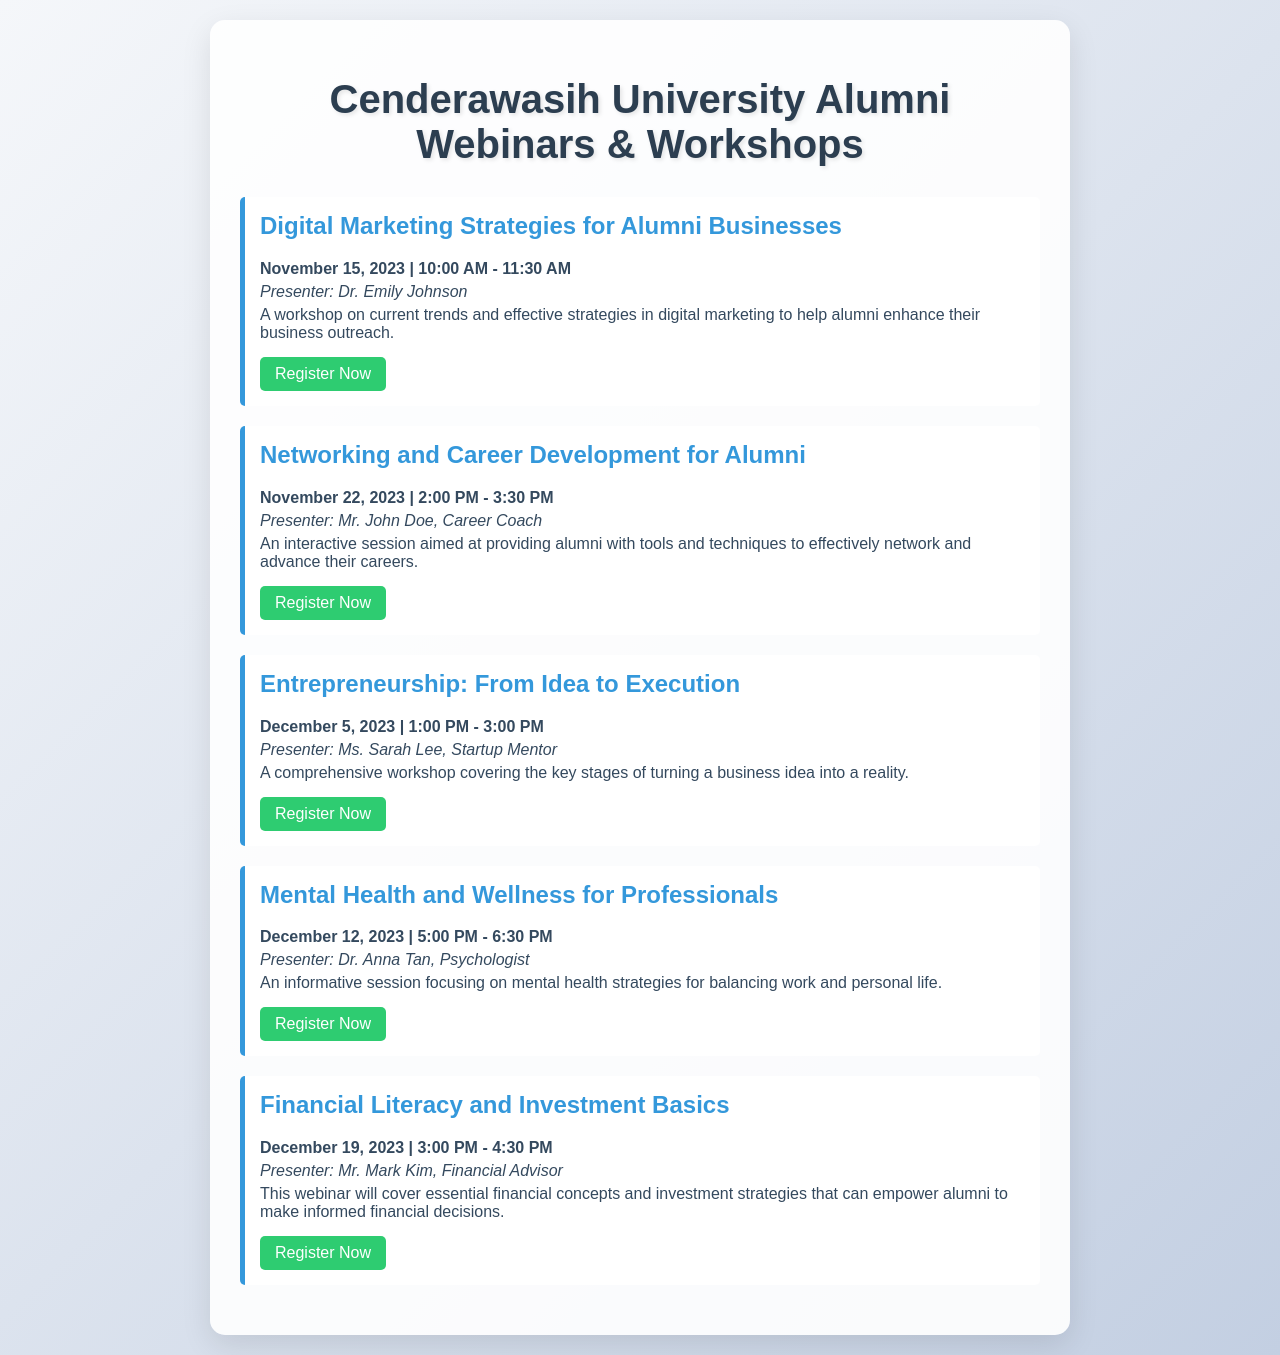What is the title of the first webinar? The title of the first webinar is listed as "Digital Marketing Strategies for Alumni Businesses."
Answer: Digital Marketing Strategies for Alumni Businesses Who is the presenter for the mental health webinar? The presenter for the mental health webinar is identified as Dr. Anna Tan, Psychologist.
Answer: Dr. Anna Tan What is the date of the entrepreneurship workshop? The date of the entrepreneurship workshop is specified as December 5, 2023.
Answer: December 5, 2023 How long is the networking session scheduled to last? The networking session is scheduled for 1.5 hours, from 2:00 PM to 3:30 PM.
Answer: 1.5 hours What is the focus of the financial literacy webinar? The focus of the financial literacy webinar is to cover essential financial concepts and investment strategies.
Answer: Financial concepts and investment strategies What is the link for registering for the digital marketing workshop? The link for registering for the digital marketing workshop is included in the document.
Answer: https://cenderawasih.edu/webinars/digital-marketing Which presenter has the profession of Career Coach? The presenter with the profession of Career Coach is listed as Mr. John Doe.
Answer: Mr. John Doe When is the last scheduled event in the document? The last scheduled event in the document is on December 19, 2023.
Answer: December 19, 2023 What topic is covered in the session by Ms. Sarah Lee? The topic covered by Ms. Sarah Lee is entrepreneurship and the process from idea to execution.
Answer: Entrepreneurship: From Idea to Execution 